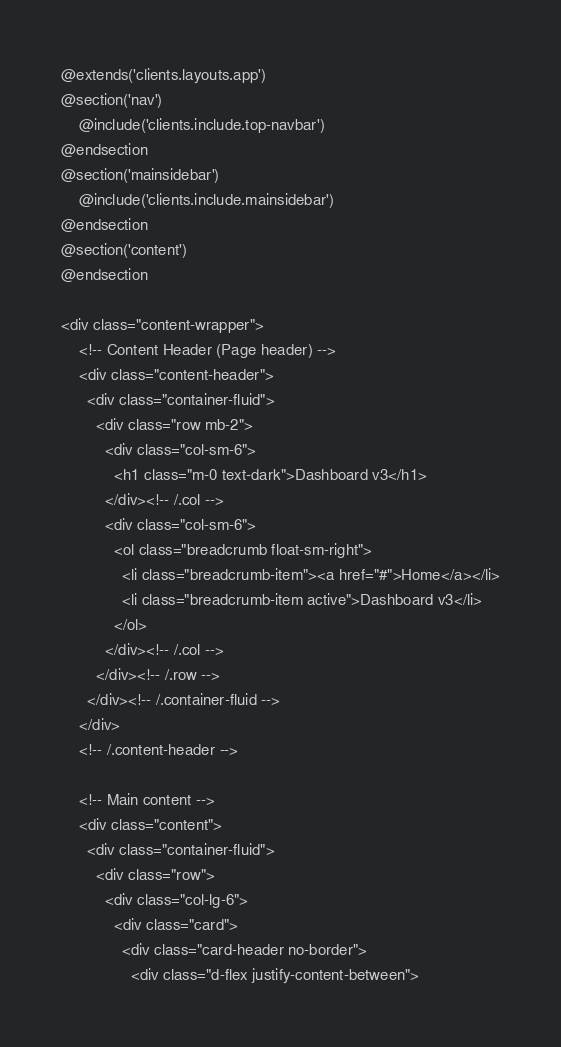Convert code to text. <code><loc_0><loc_0><loc_500><loc_500><_PHP_>@extends('clients.layouts.app')
@section('nav')
    @include('clients.include.top-navbar')
@endsection  
@section('mainsidebar')
    @include('clients.include.mainsidebar')
@endsection
@section('content')
@endsection

<div class="content-wrapper">
    <!-- Content Header (Page header) -->
    <div class="content-header">
      <div class="container-fluid">
        <div class="row mb-2">
          <div class="col-sm-6">
            <h1 class="m-0 text-dark">Dashboard v3</h1>
          </div><!-- /.col -->
          <div class="col-sm-6">
            <ol class="breadcrumb float-sm-right">
              <li class="breadcrumb-item"><a href="#">Home</a></li>
              <li class="breadcrumb-item active">Dashboard v3</li>
            </ol>
          </div><!-- /.col -->
        </div><!-- /.row -->
      </div><!-- /.container-fluid -->
    </div>
    <!-- /.content-header -->

    <!-- Main content -->
    <div class="content">
      <div class="container-fluid">
        <div class="row">
          <div class="col-lg-6">
            <div class="card">
              <div class="card-header no-border">
                <div class="d-flex justify-content-between"></code> 